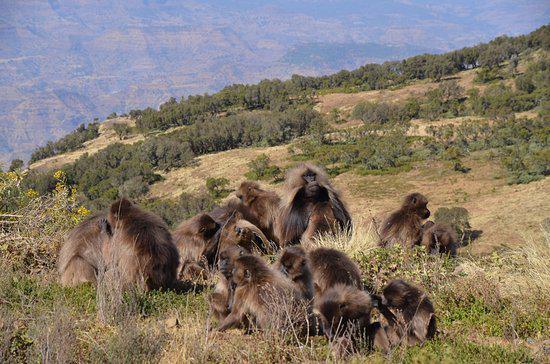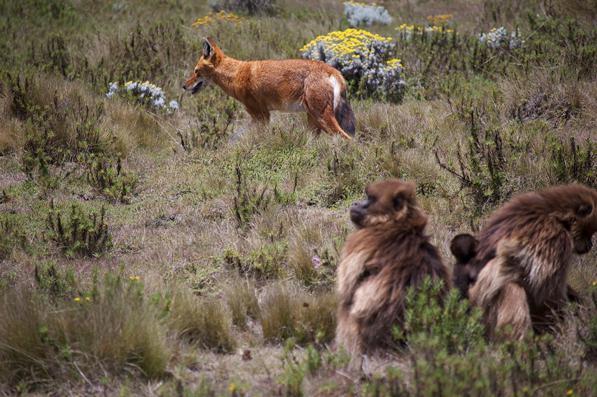The first image is the image on the left, the second image is the image on the right. For the images displayed, is the sentence "A red fox-like animal is standing in a scene near some monkeys." factually correct? Answer yes or no. Yes. 